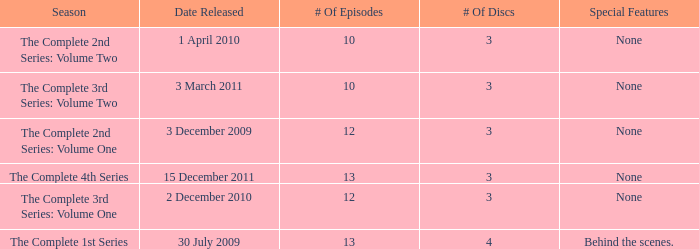How many discs for the complete 4th series? 3.0. 